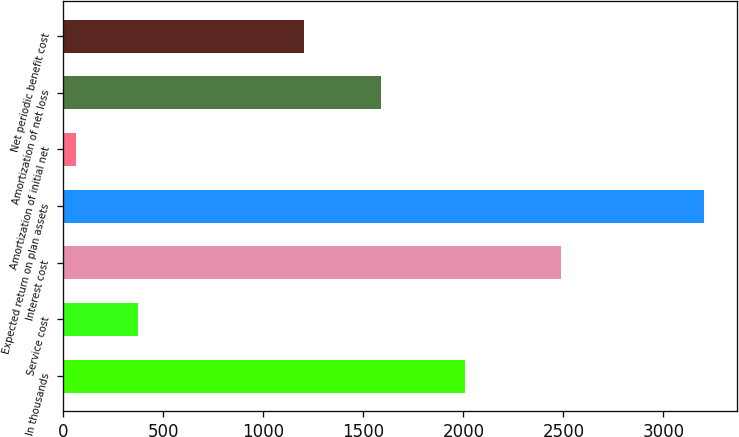<chart> <loc_0><loc_0><loc_500><loc_500><bar_chart><fcel>In thousands<fcel>Service cost<fcel>Interest cost<fcel>Expected return on plan assets<fcel>Amortization of initial net<fcel>Amortization of net loss<fcel>Net periodic benefit cost<nl><fcel>2010<fcel>376.3<fcel>2488<fcel>3205<fcel>62<fcel>1590<fcel>1202<nl></chart> 